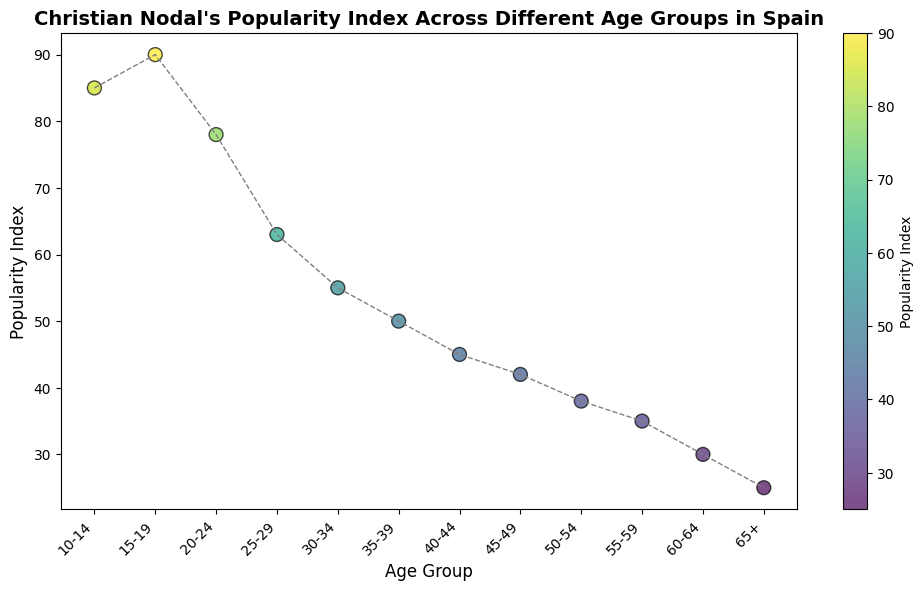Which age group has the highest popularity index for Christian Nodal? The plot shows the popularity indexes across different age groups, and the highest point on the plot corresponds to the age group 15-19.
Answer: 15-19 Which age group has the lowest popularity index for Christian Nodal? The plot shows the popularity indexes across different age groups, and the lowest point on the plot corresponds to the age group 65+.
Answer: 65+ How does the popularity index of the 25-29 age group compare to the 20-24 age group? By comparing the points on the plot, the 25-29 age group has a popularity index of 63, which is lower than the 78 of the 20-24 age group.
Answer: The 25-29 age group's index is lower What is the average popularity index of the 10-14 and 15-19 age groups? The popularity indexes for the 10-14 and 15-19 age groups are 85 and 90 respectively. The average is calculated as (85 + 90) / 2 = 87.5.
Answer: 87.5 Which age group shows more popularity for Christian Nodal, 35-39 or 55-59? By comparing the two points on the plot, the 35-39 age group has a popularity index of 50, while the 55-59 age group has an index of 35.
Answer: 35-39 What trend in popularity can be observed from age group 10-14 to age group 65+? Observing the points from left to right, there is a general downward trend in the popularity index as the age groups increase.
Answer: Popularity decreases with age What is the combined popularity index of the age groups 30-34 and 50-54? The popularity indexes for the 30-34 and 50-54 age groups are 55 and 38 respectively. The combined index is 55 + 38 = 93.
Answer: 93 What color is usually represented for higher popularity indexes on the plot? Observing the color gradient, higher popularity indexes are represented by colors like yellow.
Answer: Yellow Between which two consecutive age groups is the largest drop in popularity index observed? Observing the plot, the largest drop seems to be between the age groups 15-19 (90) and 20-24 (78), which is a drop of 12 points.
Answer: 15-19 to 20-24 Which age group is closest in popularity index to the average popularity index of age groups 25-29, 30-34, and 35-39? Calculate the average popularity index for these groups: (63 + 55 + 50) / 3 = 56. The age group closest to this average value is 30-34, with a value of 55.
Answer: 30-34 